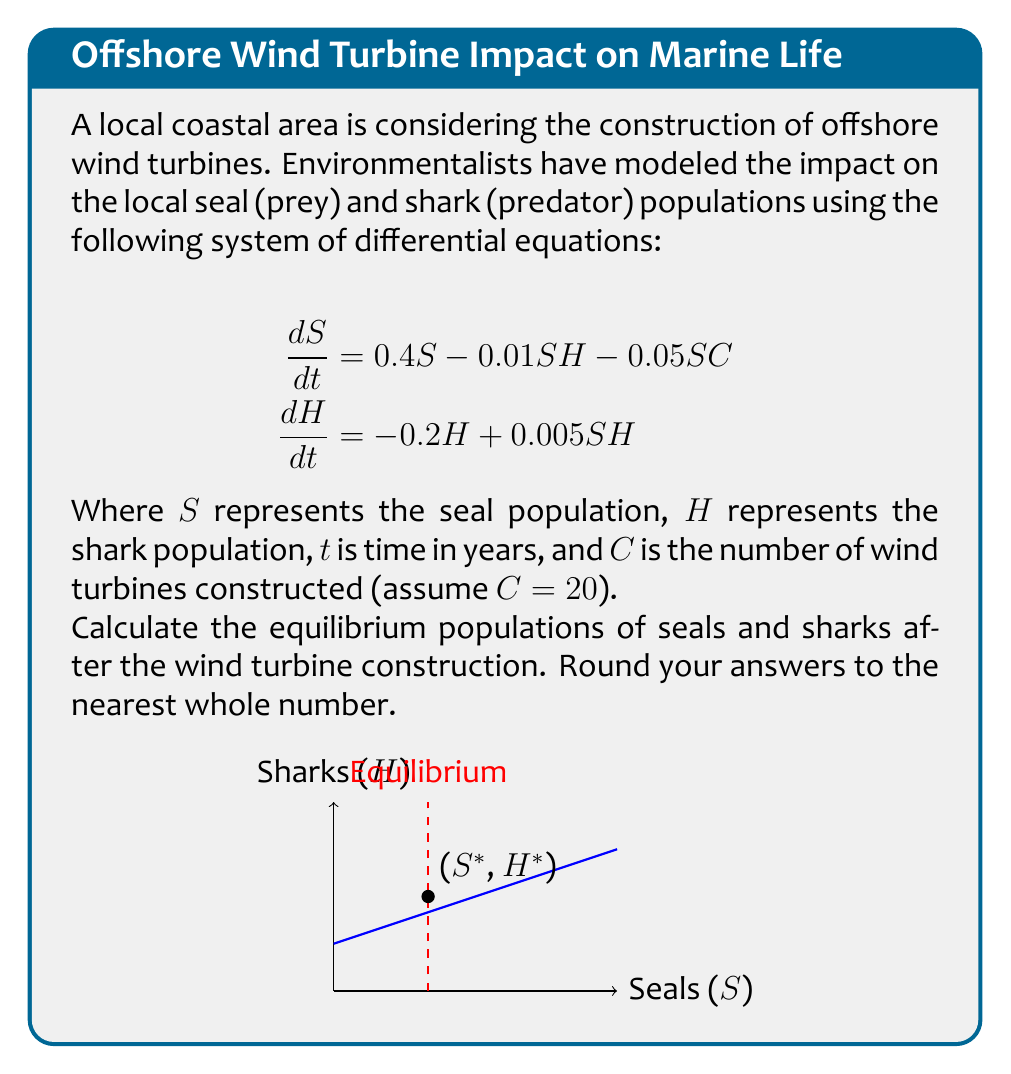What is the answer to this math problem? To find the equilibrium populations, we need to set both equations equal to zero and solve for S and H:

1) Set equations to zero:
   $$\begin{aligned}
   0 &= 0.4S - 0.01SH - 0.05SC \\
   0 &= -0.2H + 0.005SH
   \end{aligned}$$

2) From the second equation:
   $$0.2H = 0.005SH$$
   $$S = 40$$

3) Substitute S = 40 and C = 20 into the first equation:
   $$\begin{aligned}
   0 &= 0.4(40) - 0.01(40)H - 0.05(40)(20) \\
   0 &= 16 - 0.4H - 40 \\
   0.4H &= -24 \\
   H &= -60
   \end{aligned}$$

4) However, a negative population is not realistic. This means the shark population will go extinct (H = 0).

5) Recalculate the seal population with H = 0:
   $$\begin{aligned}
   0 &= 0.4S - 0.05SC \\
   0 &= 0.4S - 0.05S(20) \\
   0 &= 0.4S - S \\
   0 &= -0.6S \\
   S &= 0
   \end{aligned}$$

6) This result suggests that both populations will eventually become extinct due to the impact of the wind turbines.
Answer: Seals: 0, Sharks: 0 